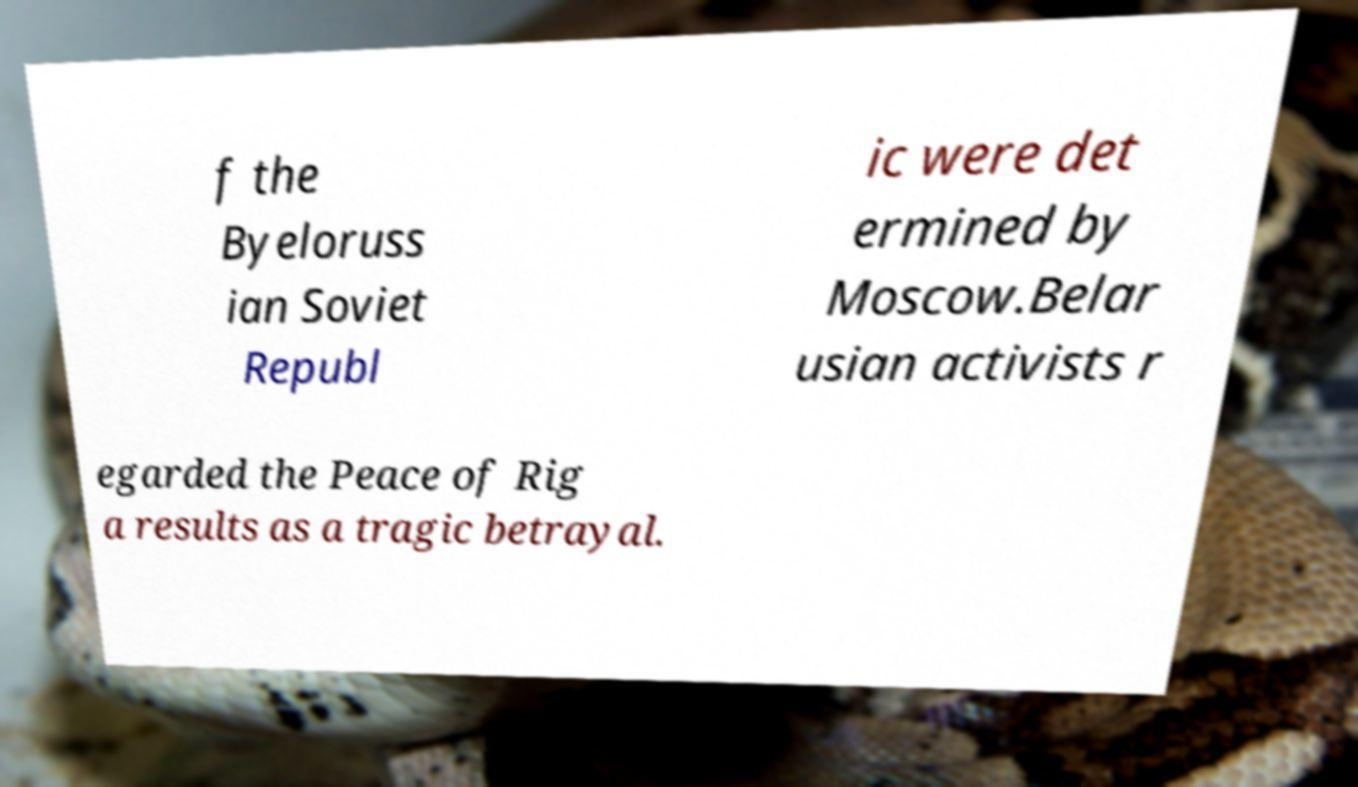Can you accurately transcribe the text from the provided image for me? f the Byeloruss ian Soviet Republ ic were det ermined by Moscow.Belar usian activists r egarded the Peace of Rig a results as a tragic betrayal. 